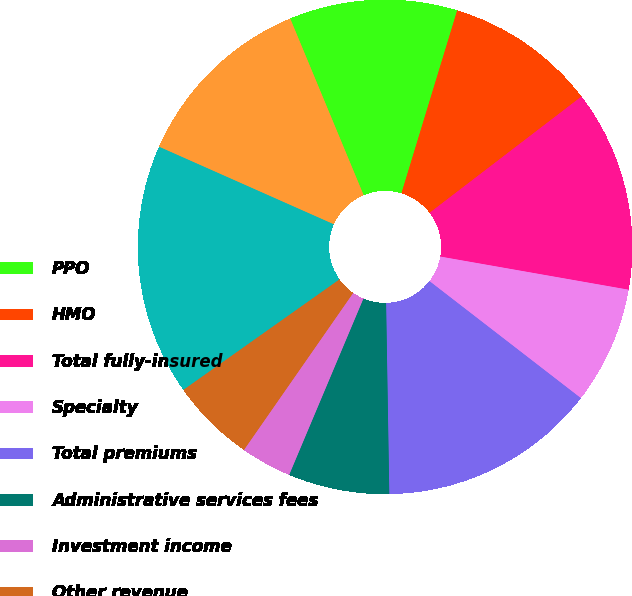<chart> <loc_0><loc_0><loc_500><loc_500><pie_chart><fcel>PPO<fcel>HMO<fcel>Total fully-insured<fcel>Specialty<fcel>Total premiums<fcel>Administrative services fees<fcel>Investment income<fcel>Other revenue<fcel>Total revenues<fcel>Benefits<nl><fcel>10.98%<fcel>9.89%<fcel>13.17%<fcel>7.7%<fcel>14.26%<fcel>6.61%<fcel>3.33%<fcel>5.52%<fcel>16.45%<fcel>12.08%<nl></chart> 